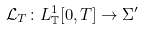Convert formula to latex. <formula><loc_0><loc_0><loc_500><loc_500>\mathcal { L } _ { T } \colon L ^ { 1 } _ { \mathbb { T } } [ 0 , T ] \rightarrow \Sigma ^ { \prime }</formula> 